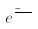<formula> <loc_0><loc_0><loc_500><loc_500>e ^ { \frac { - i a t } { } }</formula> 